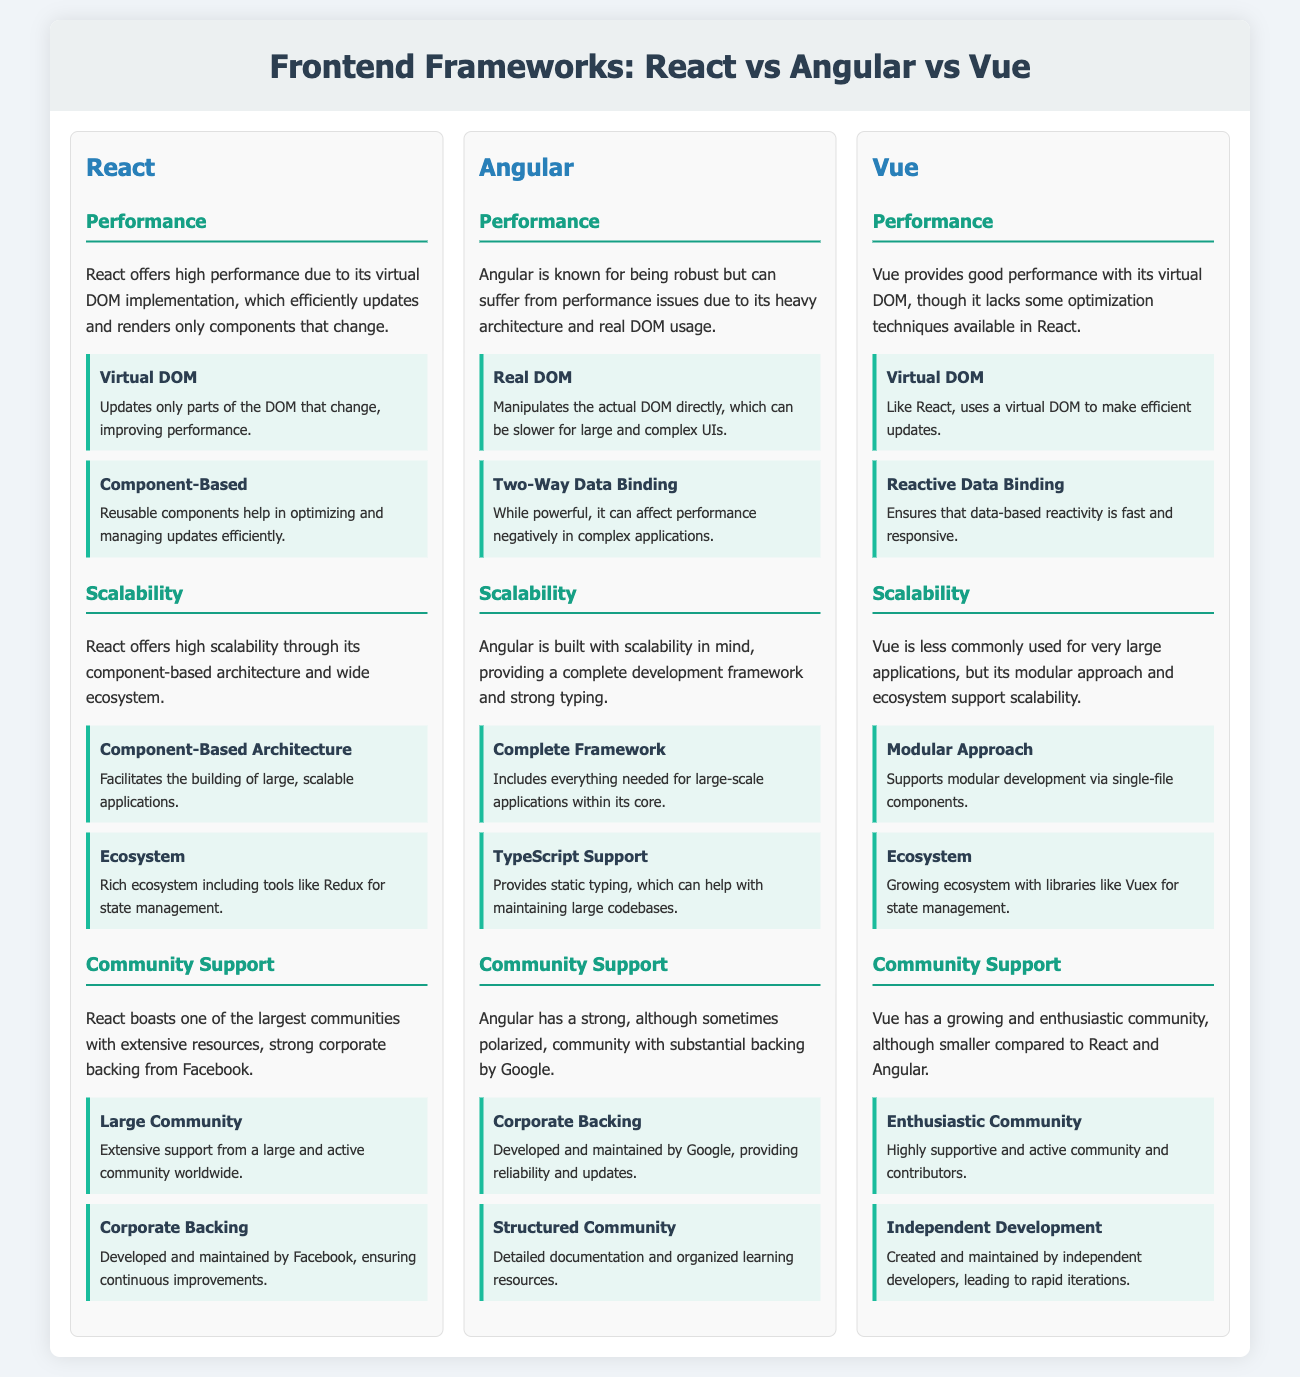What is the primary performance advantage of React? React's performance advantage comes from its virtual DOM implementation, which updates and renders only components that change.
Answer: Virtual DOM Which framework has the heaviest architecture impacting performance? Angular is known for having a heavy architecture, which can lead to performance issues.
Answer: Angular How does Vue ensure fast data reactivity? Vue ensures fast data reactivity through its reactive data binding technique.
Answer: Reactive Data Binding What type of community support does React have? React boasts a large community with strong corporate backing.
Answer: Large Community Which framework provides static typing for maintaining large codebases? Angular supports static typing, which is useful for maintaining large codebases.
Answer: TypeScript Support Among the three frameworks, which has a smaller community? Vue has a smaller community compared to React and Angular.
Answer: Vue What aspect of React contributes to its scalability? React's scalability is facilitated by its component-based architecture.
Answer: Component-Based Architecture Which framework is developed and maintained by Google? Angular is developed and maintained by Google.
Answer: Angular What is a unique feature Vue supports for modular development? Vue supports modular development through single-file components.
Answer: Single-File Components 